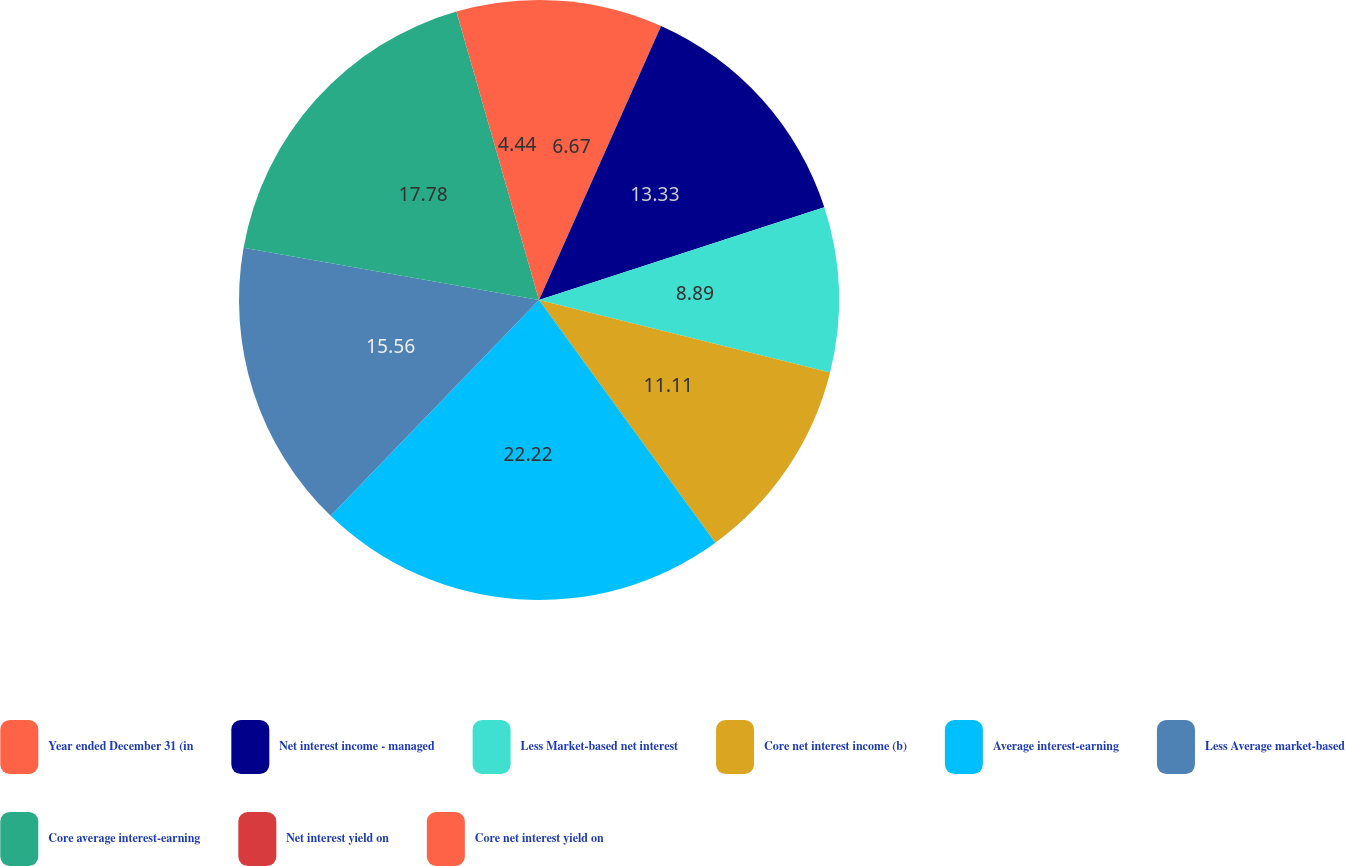Convert chart. <chart><loc_0><loc_0><loc_500><loc_500><pie_chart><fcel>Year ended December 31 (in<fcel>Net interest income - managed<fcel>Less Market-based net interest<fcel>Core net interest income (b)<fcel>Average interest-earning<fcel>Less Average market-based<fcel>Core average interest-earning<fcel>Net interest yield on<fcel>Core net interest yield on<nl><fcel>6.67%<fcel>13.33%<fcel>8.89%<fcel>11.11%<fcel>22.22%<fcel>15.56%<fcel>17.78%<fcel>0.0%<fcel>4.44%<nl></chart> 